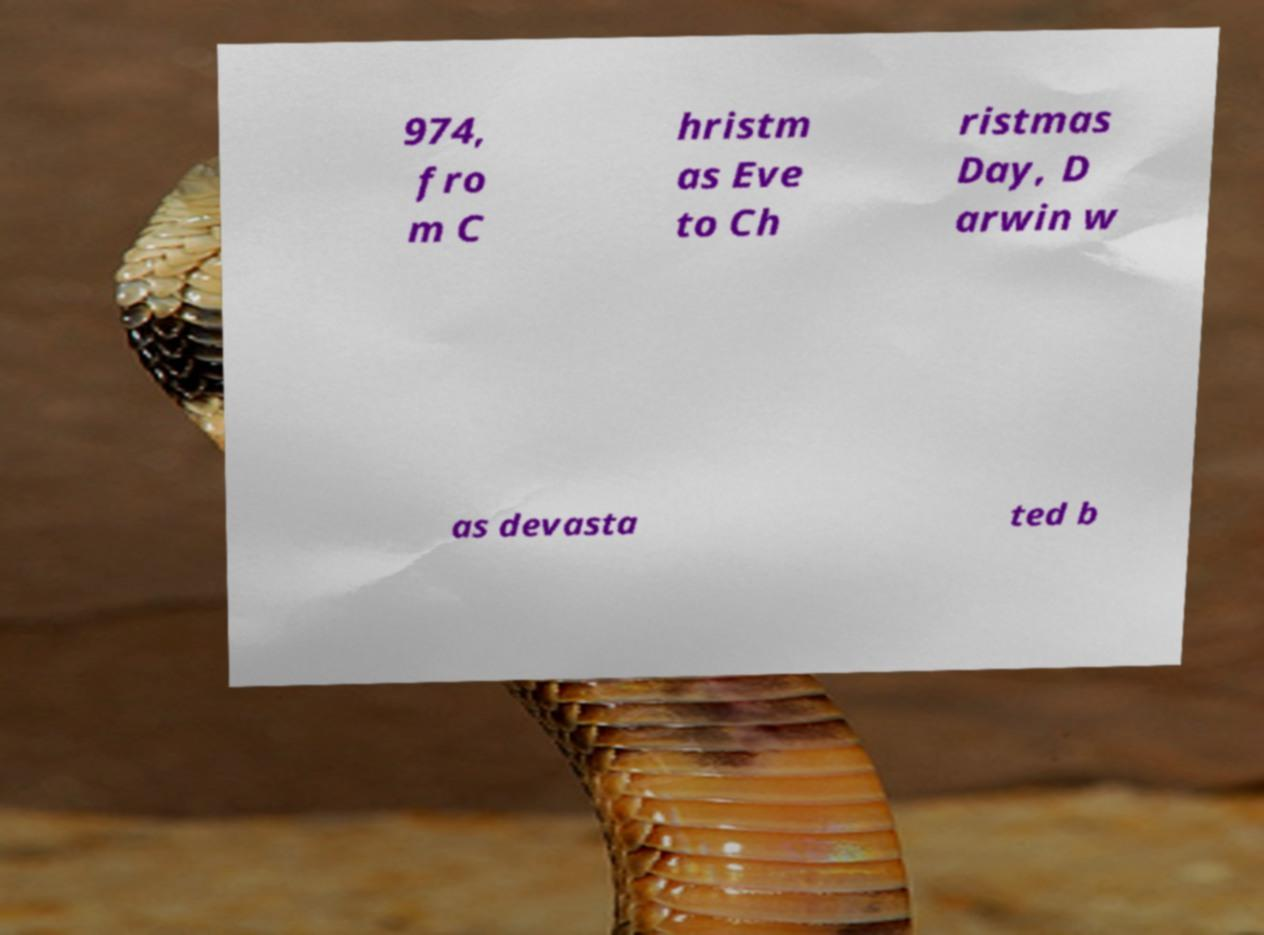There's text embedded in this image that I need extracted. Can you transcribe it verbatim? 974, fro m C hristm as Eve to Ch ristmas Day, D arwin w as devasta ted b 